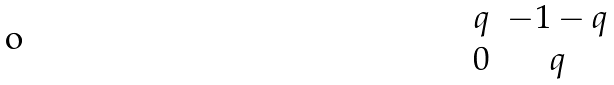Convert formula to latex. <formula><loc_0><loc_0><loc_500><loc_500>\begin{matrix} q & - 1 - q \\ 0 & q \end{matrix}</formula> 